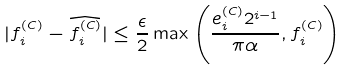Convert formula to latex. <formula><loc_0><loc_0><loc_500><loc_500>| f ^ { ( C ) } _ { i } - \widehat { f ^ { ( C ) } _ { i } } | \leq \frac { \epsilon } { 2 } \max \left ( \frac { e ^ { ( C ) } _ { i } 2 ^ { i - 1 } } { \pi \alpha } , f ^ { ( C ) } _ { i } \right )</formula> 